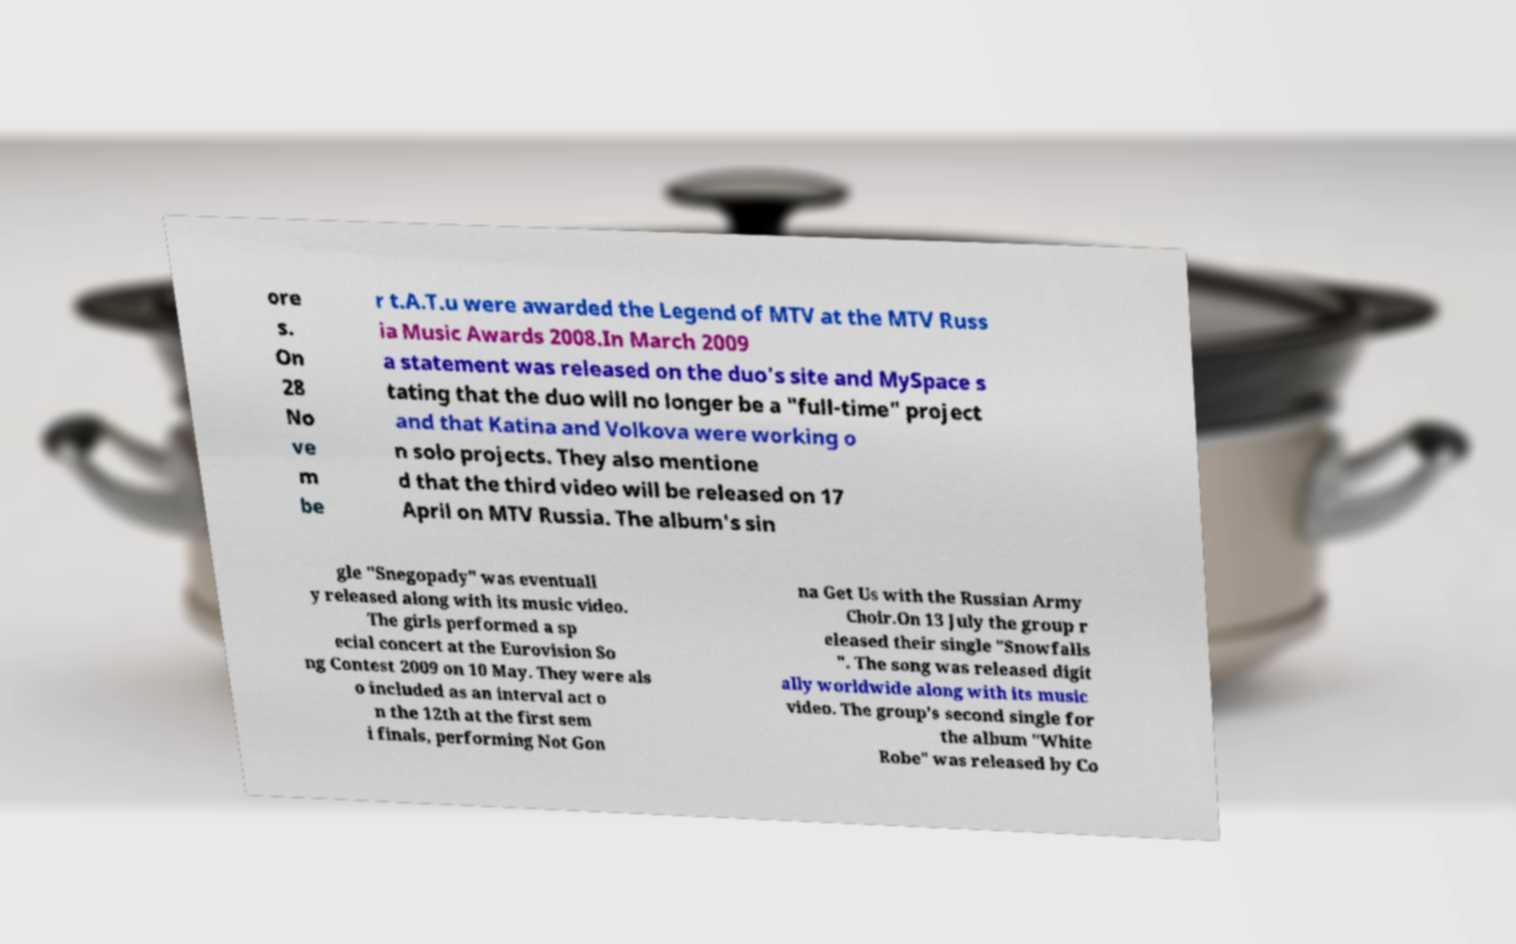Could you extract and type out the text from this image? ore s. On 28 No ve m be r t.A.T.u were awarded the Legend of MTV at the MTV Russ ia Music Awards 2008.In March 2009 a statement was released on the duo's site and MySpace s tating that the duo will no longer be a "full-time" project and that Katina and Volkova were working o n solo projects. They also mentione d that the third video will be released on 17 April on MTV Russia. The album's sin gle "Snegopady" was eventuall y released along with its music video. The girls performed a sp ecial concert at the Eurovision So ng Contest 2009 on 10 May. They were als o included as an interval act o n the 12th at the first sem i finals, performing Not Gon na Get Us with the Russian Army Choir.On 13 July the group r eleased their single "Snowfalls ". The song was released digit ally worldwide along with its music video. The group's second single for the album "White Robe" was released by Co 